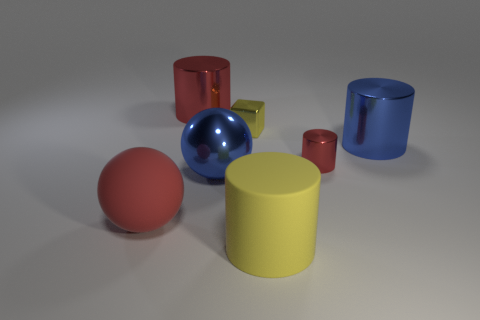Subtract all matte cylinders. How many cylinders are left? 3 Add 2 big blue spheres. How many objects exist? 9 Subtract all blue cylinders. How many cylinders are left? 3 Subtract all balls. How many objects are left? 5 Subtract all yellow cylinders. How many blue balls are left? 1 Subtract 4 cylinders. How many cylinders are left? 0 Subtract all brown cylinders. Subtract all brown balls. How many cylinders are left? 4 Subtract all big brown metallic blocks. Subtract all small red shiny things. How many objects are left? 6 Add 7 yellow shiny things. How many yellow shiny things are left? 8 Add 6 yellow shiny objects. How many yellow shiny objects exist? 7 